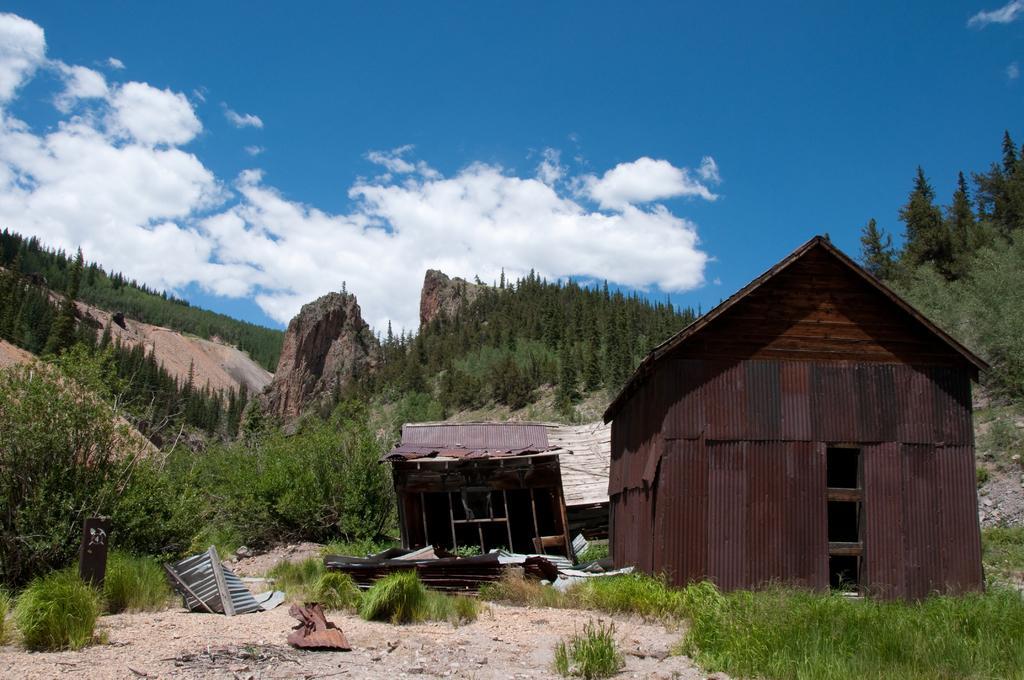In one or two sentences, can you explain what this image depicts? In this image there is a land, on that land there are plants, in the background there are sheds, trees, mountains and the sky. 